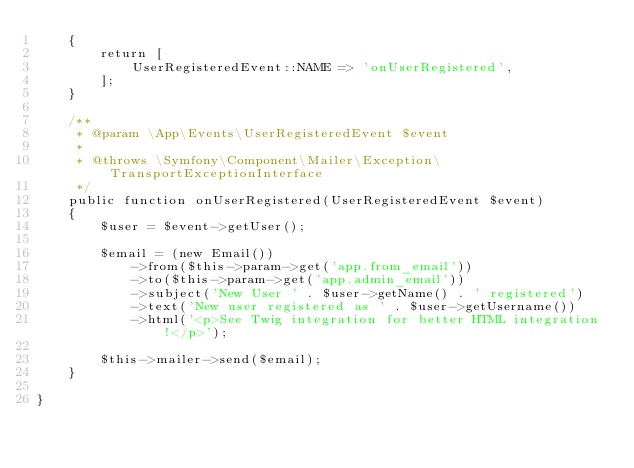<code> <loc_0><loc_0><loc_500><loc_500><_PHP_>    {
        return [
            UserRegisteredEvent::NAME => 'onUserRegistered',
        ];
    }

    /**
     * @param \App\Events\UserRegisteredEvent $event
     *
     * @throws \Symfony\Component\Mailer\Exception\TransportExceptionInterface
     */
    public function onUserRegistered(UserRegisteredEvent $event)
    {
        $user = $event->getUser();

        $email = (new Email())
            ->from($this->param->get('app.from_email'))
            ->to($this->param->get('app.admin_email'))
            ->subject('New User ' . $user->getName() . ' registered')
            ->text('New user registered as ' . $user->getUsername())
            ->html('<p>See Twig integration for better HTML integration!</p>');

        $this->mailer->send($email);
    }

}
</code> 